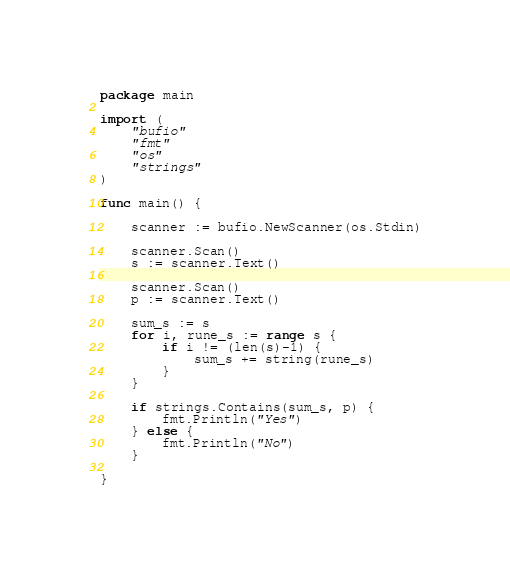Convert code to text. <code><loc_0><loc_0><loc_500><loc_500><_Go_>package main

import (
	"bufio"
	"fmt"
	"os"
	"strings"
)

func main() {

	scanner := bufio.NewScanner(os.Stdin)

	scanner.Scan()
	s := scanner.Text()

	scanner.Scan()
	p := scanner.Text()

	sum_s := s
	for i, rune_s := range s {
		if i != (len(s)-1) {
			sum_s += string(rune_s)
		}
	}

	if strings.Contains(sum_s, p) {
		fmt.Println("Yes")
	} else {
		fmt.Println("No")
	}

}

</code> 